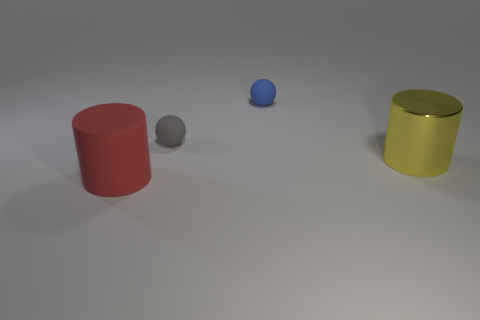Add 4 small gray balls. How many objects exist? 8 Subtract all large brown shiny balls. Subtract all big matte cylinders. How many objects are left? 3 Add 1 rubber spheres. How many rubber spheres are left? 3 Add 4 blue rubber balls. How many blue rubber balls exist? 5 Subtract 0 green cubes. How many objects are left? 4 